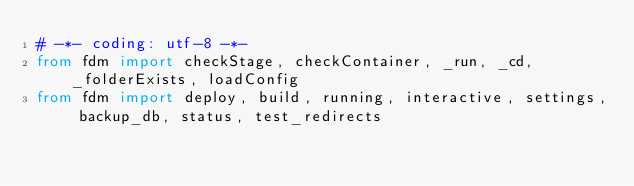Convert code to text. <code><loc_0><loc_0><loc_500><loc_500><_Python_># -*- coding: utf-8 -*-
from fdm import checkStage, checkContainer, _run, _cd, _folderExists, loadConfig
from fdm import deploy, build, running, interactive, settings, backup_db, status, test_redirects
</code> 